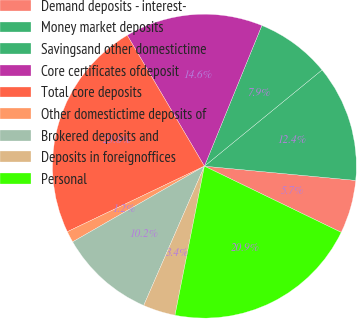Convert chart. <chart><loc_0><loc_0><loc_500><loc_500><pie_chart><fcel>Demand deposits - interest-<fcel>Money market deposits<fcel>Savingsand other domestictime<fcel>Core certificates ofdeposit<fcel>Total core deposits<fcel>Other domestictime deposits of<fcel>Brokered deposits and<fcel>Deposits in foreignoffices<fcel>Personal<nl><fcel>5.68%<fcel>12.41%<fcel>7.92%<fcel>14.65%<fcel>23.62%<fcel>1.2%<fcel>10.16%<fcel>3.44%<fcel>20.93%<nl></chart> 